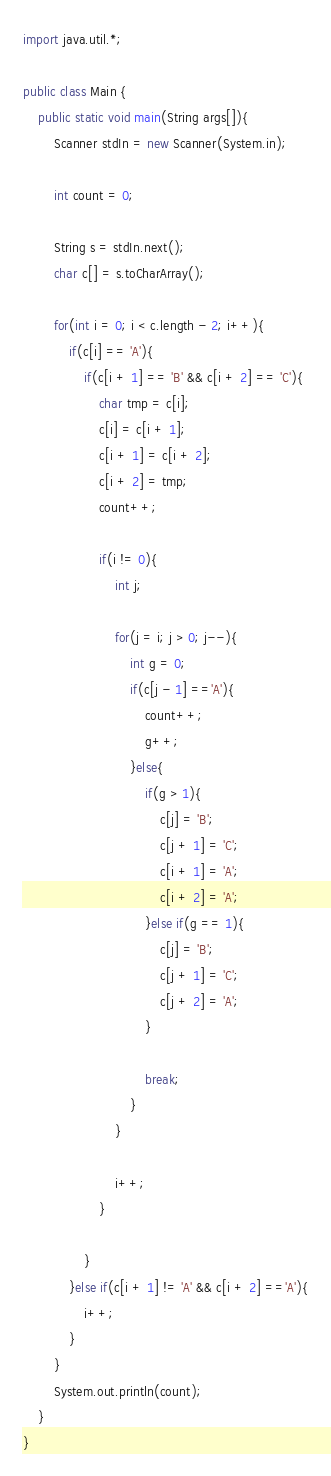Convert code to text. <code><loc_0><loc_0><loc_500><loc_500><_Java_>import java.util.*;
 
public class Main {
    public static void main(String args[]){
        Scanner stdIn = new Scanner(System.in);
        
        int count = 0;
        
        String s = stdIn.next();
        char c[] = s.toCharArray();
        
        for(int i = 0; i < c.length - 2; i++){
            if(c[i] == 'A'){
                if(c[i + 1] == 'B' && c[i + 2] == 'C'){
                    char tmp = c[i];
                    c[i] = c[i + 1];
                    c[i + 1] = c[i + 2]; 
                    c[i + 2] = tmp;
                    count++;
                    
                    if(i != 0){
                        int j;
                        
                        for(j = i; j > 0; j--){
                            int g = 0;
                            if(c[j - 1] =='A'){
                                count++;
                                g++;
                            }else{
                                if(g > 1){
                                    c[j] = 'B';
                                    c[j + 1] = 'C';
                                    c[i + 1] = 'A'; 
                                    c[i + 2] = 'A';
                                }else if(g == 1){
                                    c[j] = 'B';
                                    c[j + 1] = 'C';
                                    c[j + 2] = 'A'; 
                                }
                                
                                break;
                            }
                        }
                            
                        i++;
                    }
                    
                }
            }else if(c[i + 1] != 'A' && c[i + 2] =='A'){
                i++;
            }
        }
        System.out.println(count);
    }
}</code> 